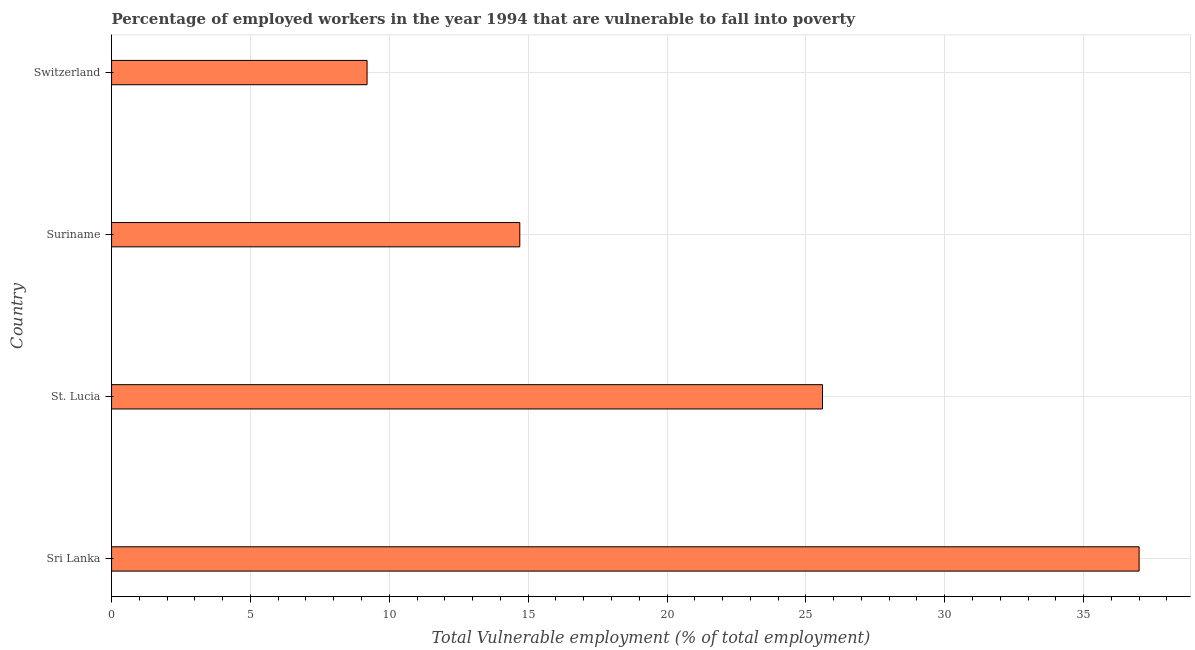Does the graph contain any zero values?
Provide a short and direct response. No. What is the title of the graph?
Your answer should be compact. Percentage of employed workers in the year 1994 that are vulnerable to fall into poverty. What is the label or title of the X-axis?
Offer a very short reply. Total Vulnerable employment (% of total employment). What is the total vulnerable employment in St. Lucia?
Make the answer very short. 25.6. Across all countries, what is the maximum total vulnerable employment?
Your answer should be compact. 37. Across all countries, what is the minimum total vulnerable employment?
Ensure brevity in your answer.  9.2. In which country was the total vulnerable employment maximum?
Keep it short and to the point. Sri Lanka. In which country was the total vulnerable employment minimum?
Give a very brief answer. Switzerland. What is the sum of the total vulnerable employment?
Provide a succinct answer. 86.5. What is the difference between the total vulnerable employment in Sri Lanka and Switzerland?
Make the answer very short. 27.8. What is the average total vulnerable employment per country?
Provide a short and direct response. 21.62. What is the median total vulnerable employment?
Your response must be concise. 20.15. What is the ratio of the total vulnerable employment in St. Lucia to that in Switzerland?
Ensure brevity in your answer.  2.78. Is the total vulnerable employment in Sri Lanka less than that in St. Lucia?
Your answer should be very brief. No. Is the sum of the total vulnerable employment in St. Lucia and Suriname greater than the maximum total vulnerable employment across all countries?
Ensure brevity in your answer.  Yes. What is the difference between the highest and the lowest total vulnerable employment?
Make the answer very short. 27.8. In how many countries, is the total vulnerable employment greater than the average total vulnerable employment taken over all countries?
Provide a succinct answer. 2. Are the values on the major ticks of X-axis written in scientific E-notation?
Your response must be concise. No. What is the Total Vulnerable employment (% of total employment) of St. Lucia?
Make the answer very short. 25.6. What is the Total Vulnerable employment (% of total employment) of Suriname?
Provide a short and direct response. 14.7. What is the Total Vulnerable employment (% of total employment) of Switzerland?
Your answer should be compact. 9.2. What is the difference between the Total Vulnerable employment (% of total employment) in Sri Lanka and Suriname?
Offer a very short reply. 22.3. What is the difference between the Total Vulnerable employment (% of total employment) in Sri Lanka and Switzerland?
Offer a terse response. 27.8. What is the difference between the Total Vulnerable employment (% of total employment) in Suriname and Switzerland?
Offer a very short reply. 5.5. What is the ratio of the Total Vulnerable employment (% of total employment) in Sri Lanka to that in St. Lucia?
Give a very brief answer. 1.45. What is the ratio of the Total Vulnerable employment (% of total employment) in Sri Lanka to that in Suriname?
Your answer should be very brief. 2.52. What is the ratio of the Total Vulnerable employment (% of total employment) in Sri Lanka to that in Switzerland?
Your answer should be very brief. 4.02. What is the ratio of the Total Vulnerable employment (% of total employment) in St. Lucia to that in Suriname?
Your answer should be compact. 1.74. What is the ratio of the Total Vulnerable employment (% of total employment) in St. Lucia to that in Switzerland?
Provide a succinct answer. 2.78. What is the ratio of the Total Vulnerable employment (% of total employment) in Suriname to that in Switzerland?
Offer a very short reply. 1.6. 